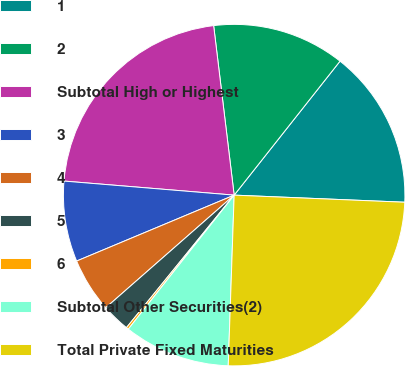<chart> <loc_0><loc_0><loc_500><loc_500><pie_chart><fcel>1<fcel>2<fcel>Subtotal High or Highest<fcel>3<fcel>4<fcel>5<fcel>6<fcel>Subtotal Other Securities(2)<fcel>Total Private Fixed Maturities<nl><fcel>15.02%<fcel>12.56%<fcel>21.77%<fcel>7.62%<fcel>5.15%<fcel>2.68%<fcel>0.22%<fcel>10.09%<fcel>24.89%<nl></chart> 